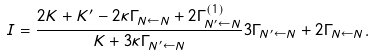<formula> <loc_0><loc_0><loc_500><loc_500>I = \frac { 2 K + K ^ { \prime } - 2 \kappa \Gamma _ { N \leftarrow N } + 2 \Gamma _ { N ^ { \prime } \leftarrow N } ^ { \left ( 1 \right ) } } { K + 3 \kappa \Gamma _ { N ^ { \prime } \leftarrow N } } 3 \Gamma _ { N ^ { \prime } \leftarrow N } + 2 \Gamma _ { N \leftarrow N } .</formula> 